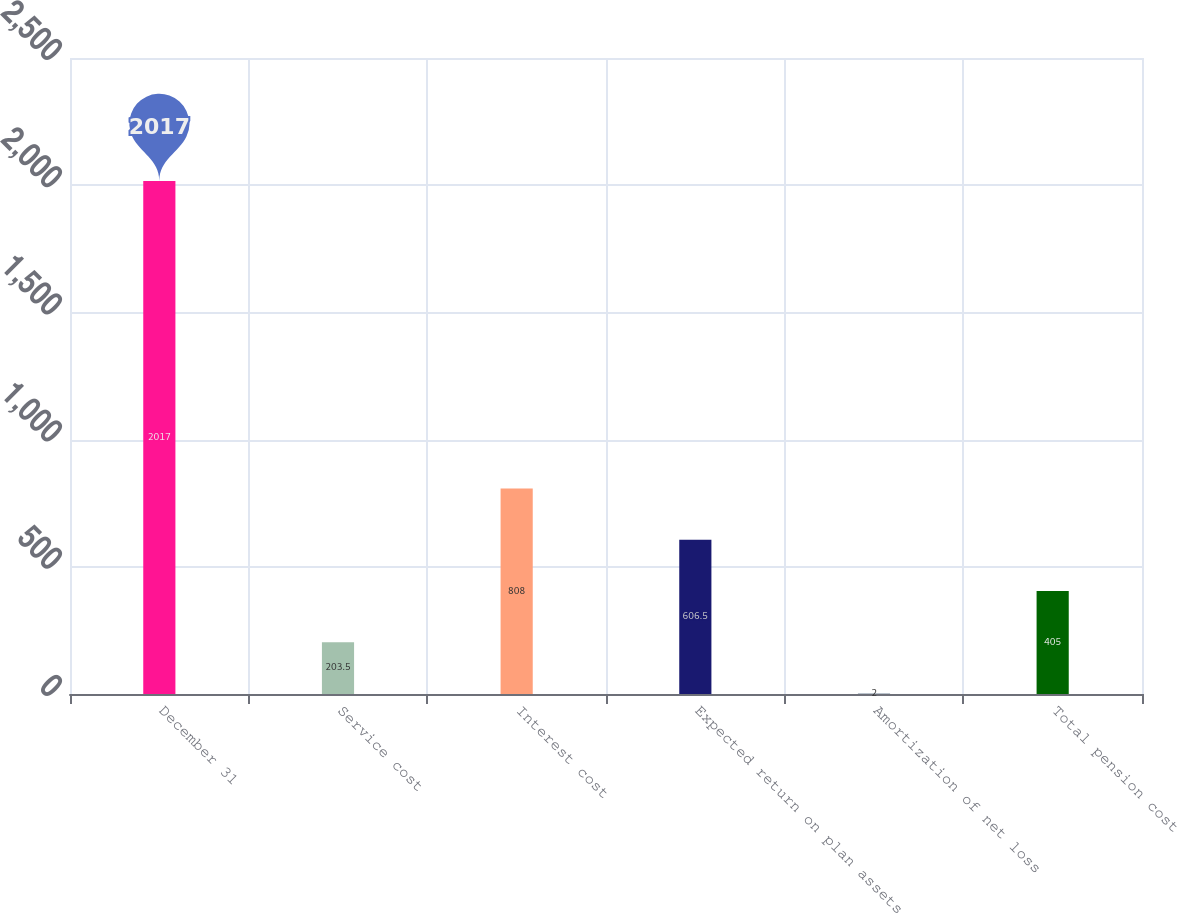Convert chart to OTSL. <chart><loc_0><loc_0><loc_500><loc_500><bar_chart><fcel>December 31<fcel>Service cost<fcel>Interest cost<fcel>Expected return on plan assets<fcel>Amortization of net loss<fcel>Total pension cost<nl><fcel>2017<fcel>203.5<fcel>808<fcel>606.5<fcel>2<fcel>405<nl></chart> 